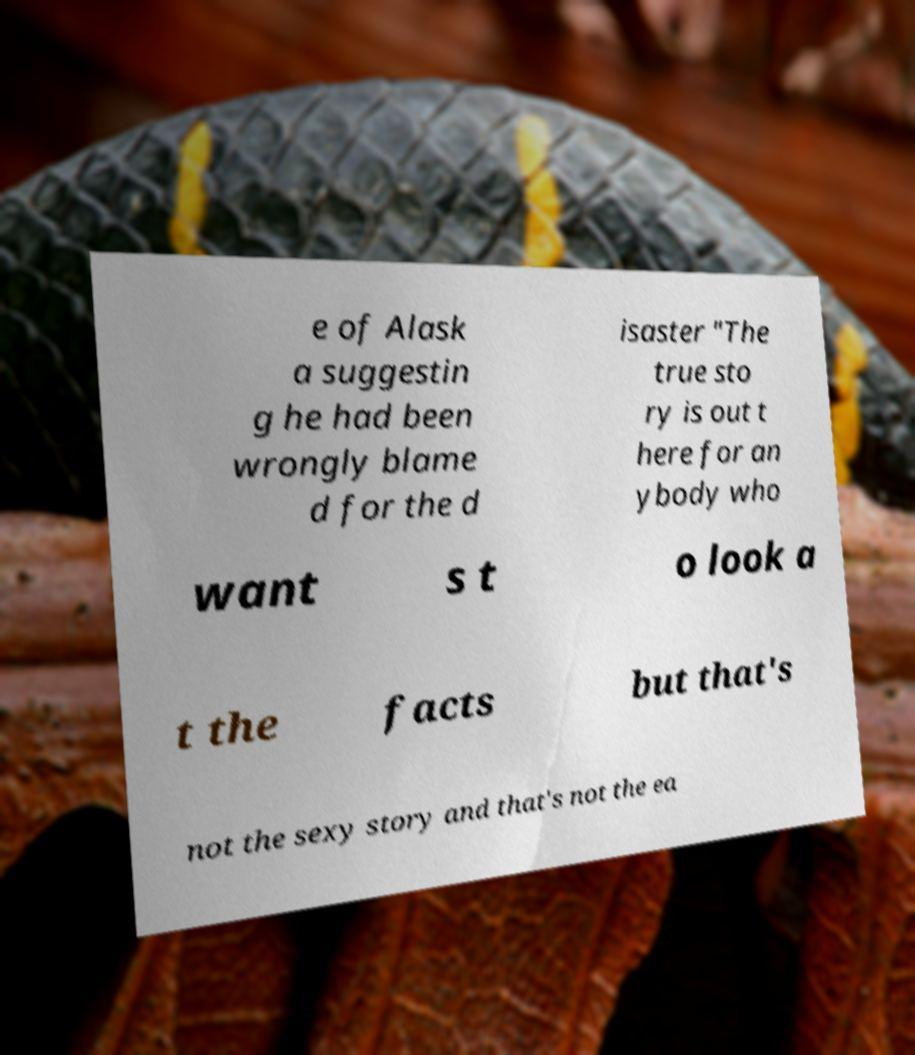I need the written content from this picture converted into text. Can you do that? e of Alask a suggestin g he had been wrongly blame d for the d isaster "The true sto ry is out t here for an ybody who want s t o look a t the facts but that's not the sexy story and that's not the ea 